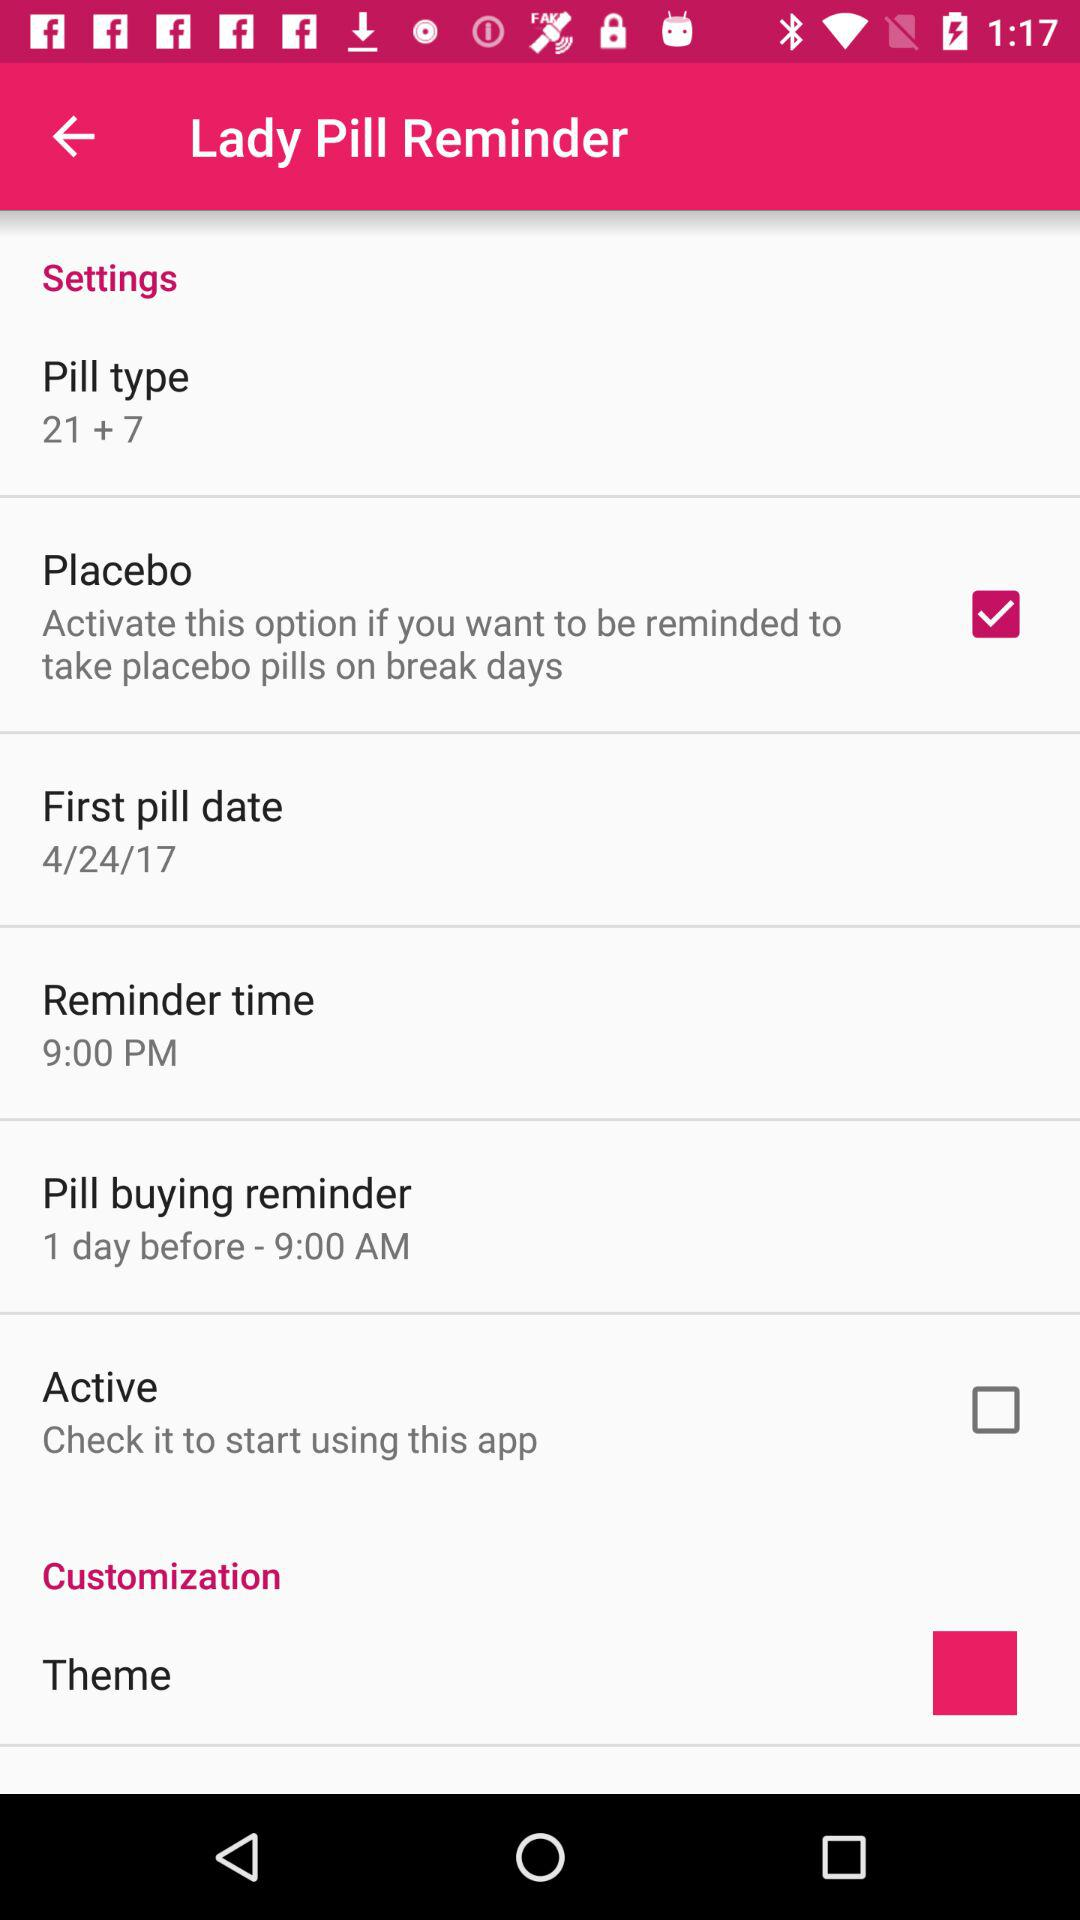What is the setting for "Pill buying reminder"? The setting for "Pill buying reminder" is "1 day before - 9:00 AM". 